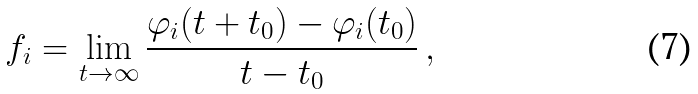<formula> <loc_0><loc_0><loc_500><loc_500>f _ { i } = \lim _ { t \to \infty } \frac { \varphi _ { i } ( t + t _ { 0 } ) - \varphi _ { i } ( t _ { 0 } ) } { t - t _ { 0 } } \, ,</formula> 